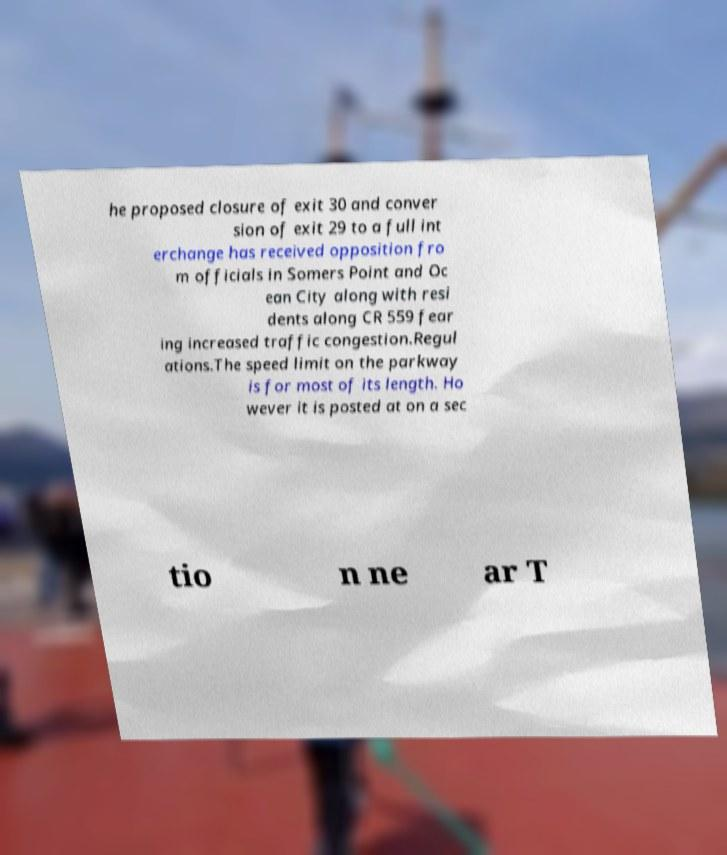What messages or text are displayed in this image? I need them in a readable, typed format. he proposed closure of exit 30 and conver sion of exit 29 to a full int erchange has received opposition fro m officials in Somers Point and Oc ean City along with resi dents along CR 559 fear ing increased traffic congestion.Regul ations.The speed limit on the parkway is for most of its length. Ho wever it is posted at on a sec tio n ne ar T 